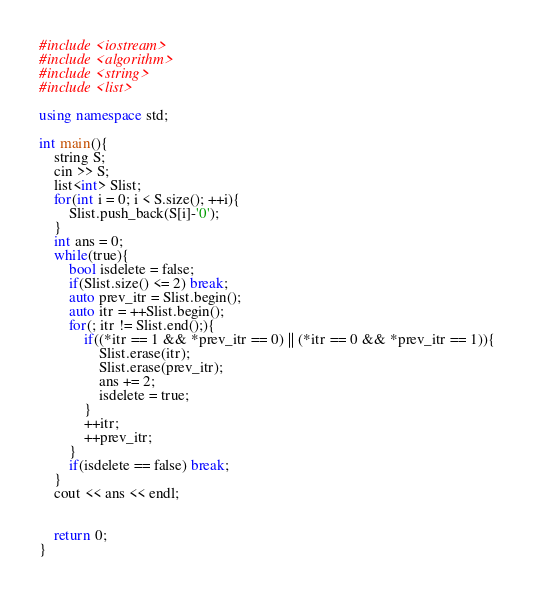Convert code to text. <code><loc_0><loc_0><loc_500><loc_500><_C++_>#include <iostream>
#include <algorithm>
#include <string>
#include <list>

using namespace std;

int main(){
    string S;
    cin >> S;
    list<int> Slist;
    for(int i = 0; i < S.size(); ++i){
        Slist.push_back(S[i]-'0');
    }
    int ans = 0;
    while(true){
        bool isdelete = false;
        if(Slist.size() <= 2) break;
        auto prev_itr = Slist.begin();
        auto itr = ++Slist.begin();
        for(; itr != Slist.end();){
            if((*itr == 1 && *prev_itr == 0) || (*itr == 0 && *prev_itr == 1)){
                Slist.erase(itr);
                Slist.erase(prev_itr);
                ans += 2;
                isdelete = true;
            }
            ++itr;
            ++prev_itr;
        }
        if(isdelete == false) break;
    }
    cout << ans << endl;


    return 0;
}</code> 